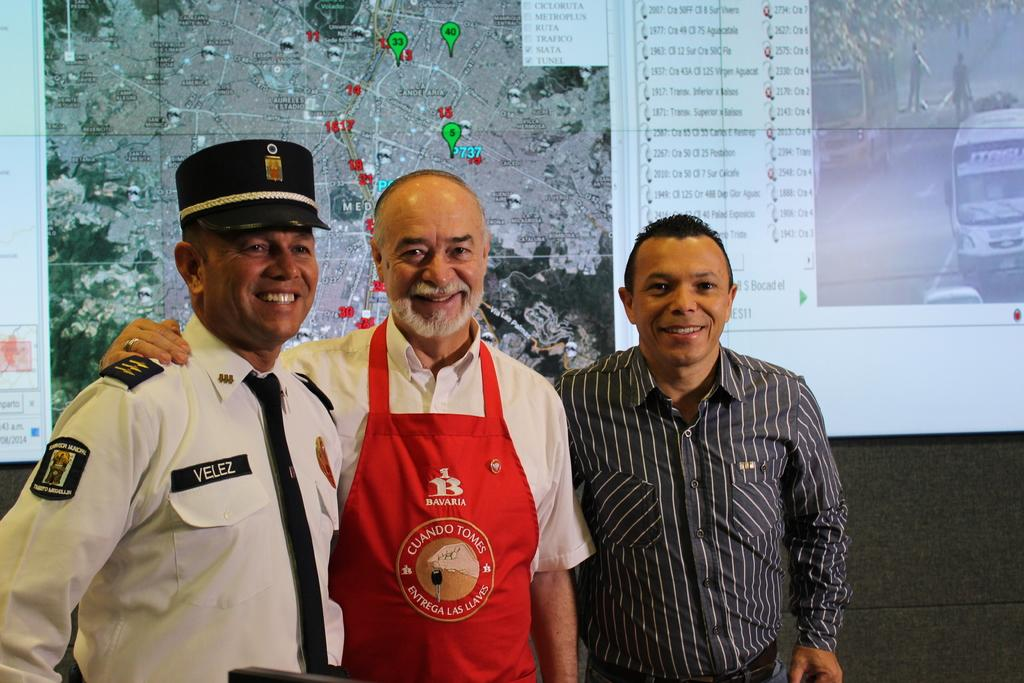Provide a one-sentence caption for the provided image. three gentlemen- a train conductor, a man with a red Bavaria apron on and regular passenger taking a picture infront of train schedule. 